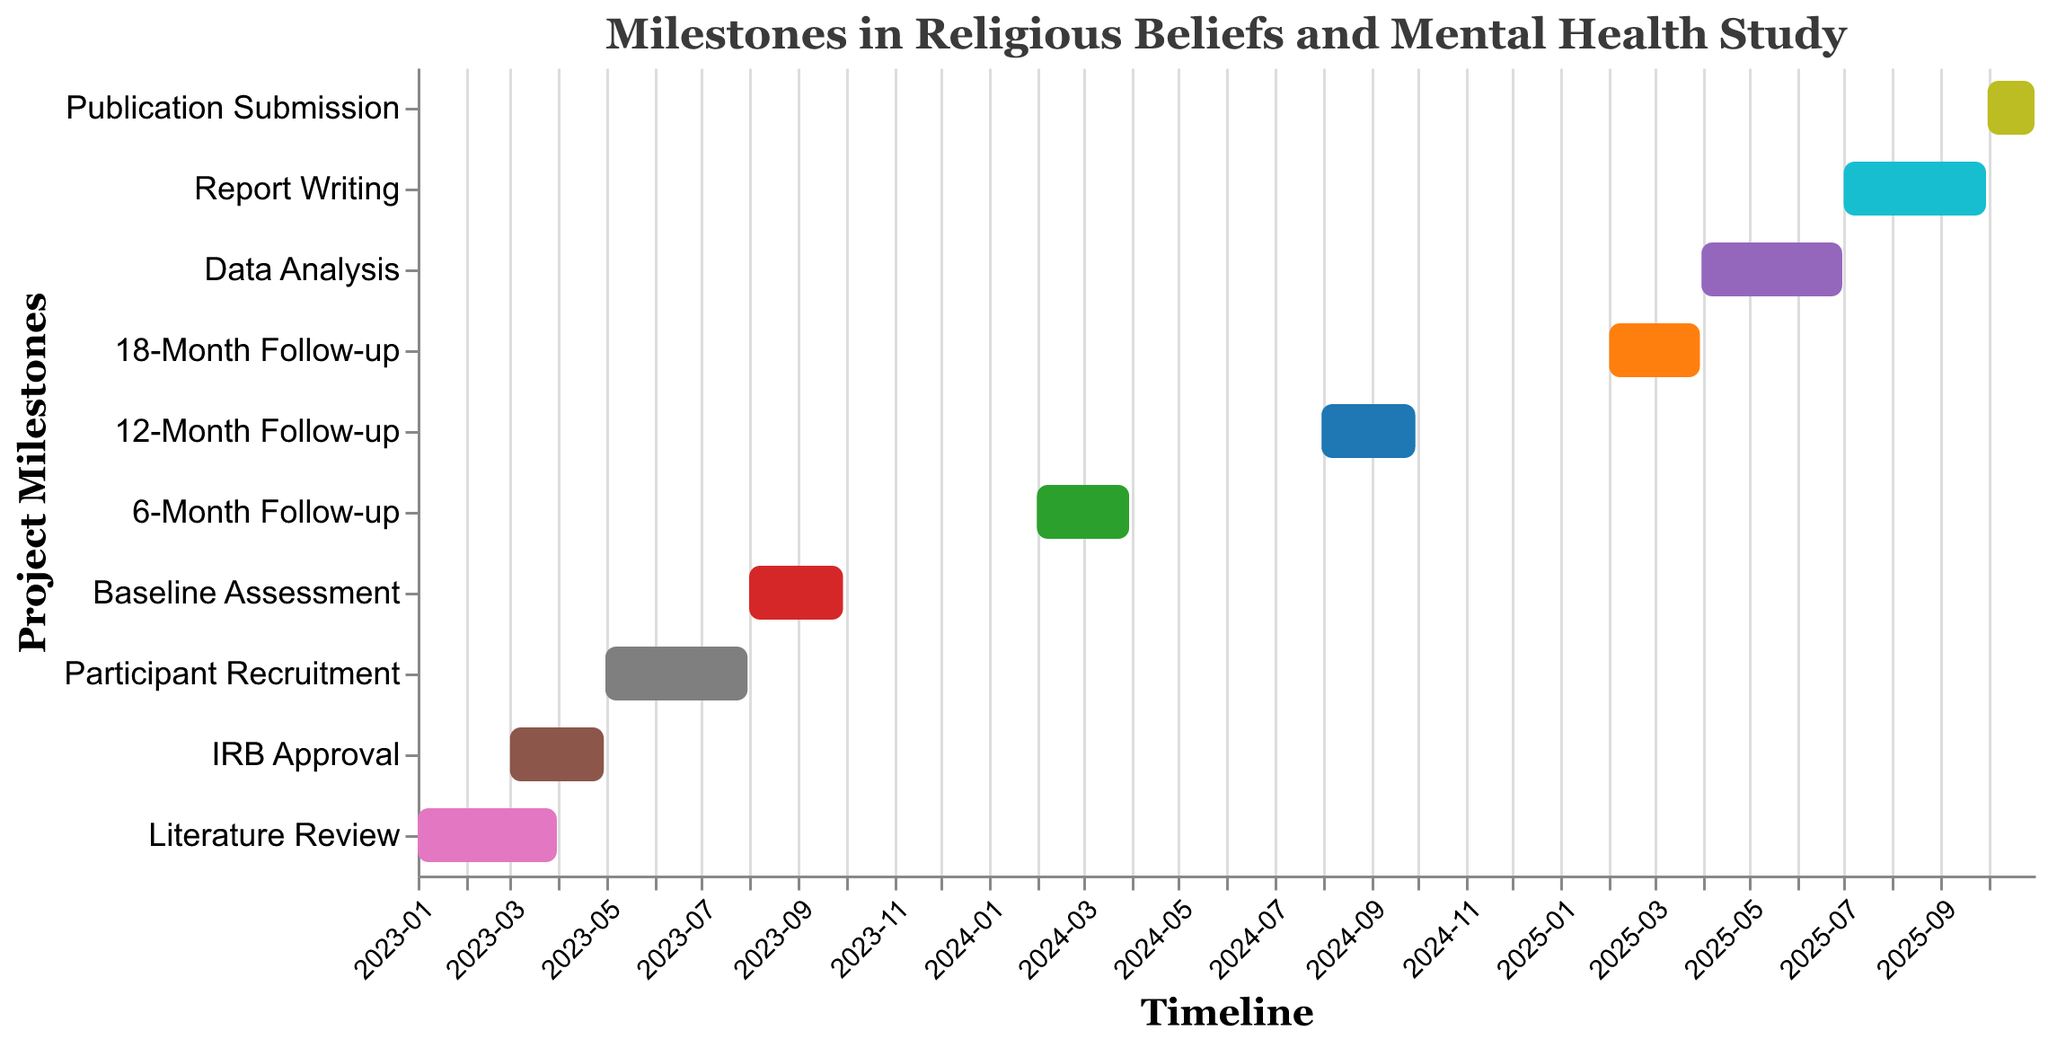How long did the Literature Review phase last? The Literature Review phase started on 2023-01-01 and ended on 2023-03-31. To calculate the duration: January has 31 days, February has 28 days (not a leap year), and March has 31 days. Adding these up gives 31 + 28 + 31 = 90 days.
Answer: 90 days Which milestone took place right after the IRB Approval? First, identify the end date of the IRB Approval, which is 2023-04-30. The next milestone starts on 2023-05-01, which is Participant Recruitment.
Answer: Participant Recruitment How many months will it take to complete the Baseline Assessment? The Baseline Assessment starts on 2023-08-01 and ends on 2023-09-30. Therefore, it takes from the beginning of August to the end of September, which is 2 months.
Answer: 2 months Which milestones overlap in time with IRB Approval? The IRB Approval period is from 2023-03-01 to 2023-04-30. The Literature Review, which ends on 2023-03-31, overlaps with IRB Approval in March.
Answer: Literature Review What is the total duration from the start of Participant Recruitment to the end of the 18-Month Follow-up? Participant Recruitment starts on 2023-05-01 and 18-Month Follow-up ends on 2025-03-31. To calculate the duration: From May 2023 to March 2025 is 1 year and 11 months or 23 months total.
Answer: 23 months How much time is allocated to Data Analysis? Data Analysis starts on 2025-04-01 and ends on 2025-06-30. From April 1 to June 30 is 3 months.
Answer: 3 months During which months does the 12-Month Follow-up occur? The 12-Month Follow-up starts on 2024-08-01 and ends on 2024-09-30. Therefore, it occurs in August and September 2024.
Answer: August and September 2024 Which milestone has the shortest duration? By examining the duration of each milestone, the Publication Submission phase, which runs from 2025-10-01 to 2025-10-31, lasts only 1 month.
Answer: Publication Submission At what point in the project timeline does Report Writing begin? Report Writing begins on 2025-07-01. This is after the Data Analysis phase, which ends on 2025-06-30.
Answer: 2025-07-01 